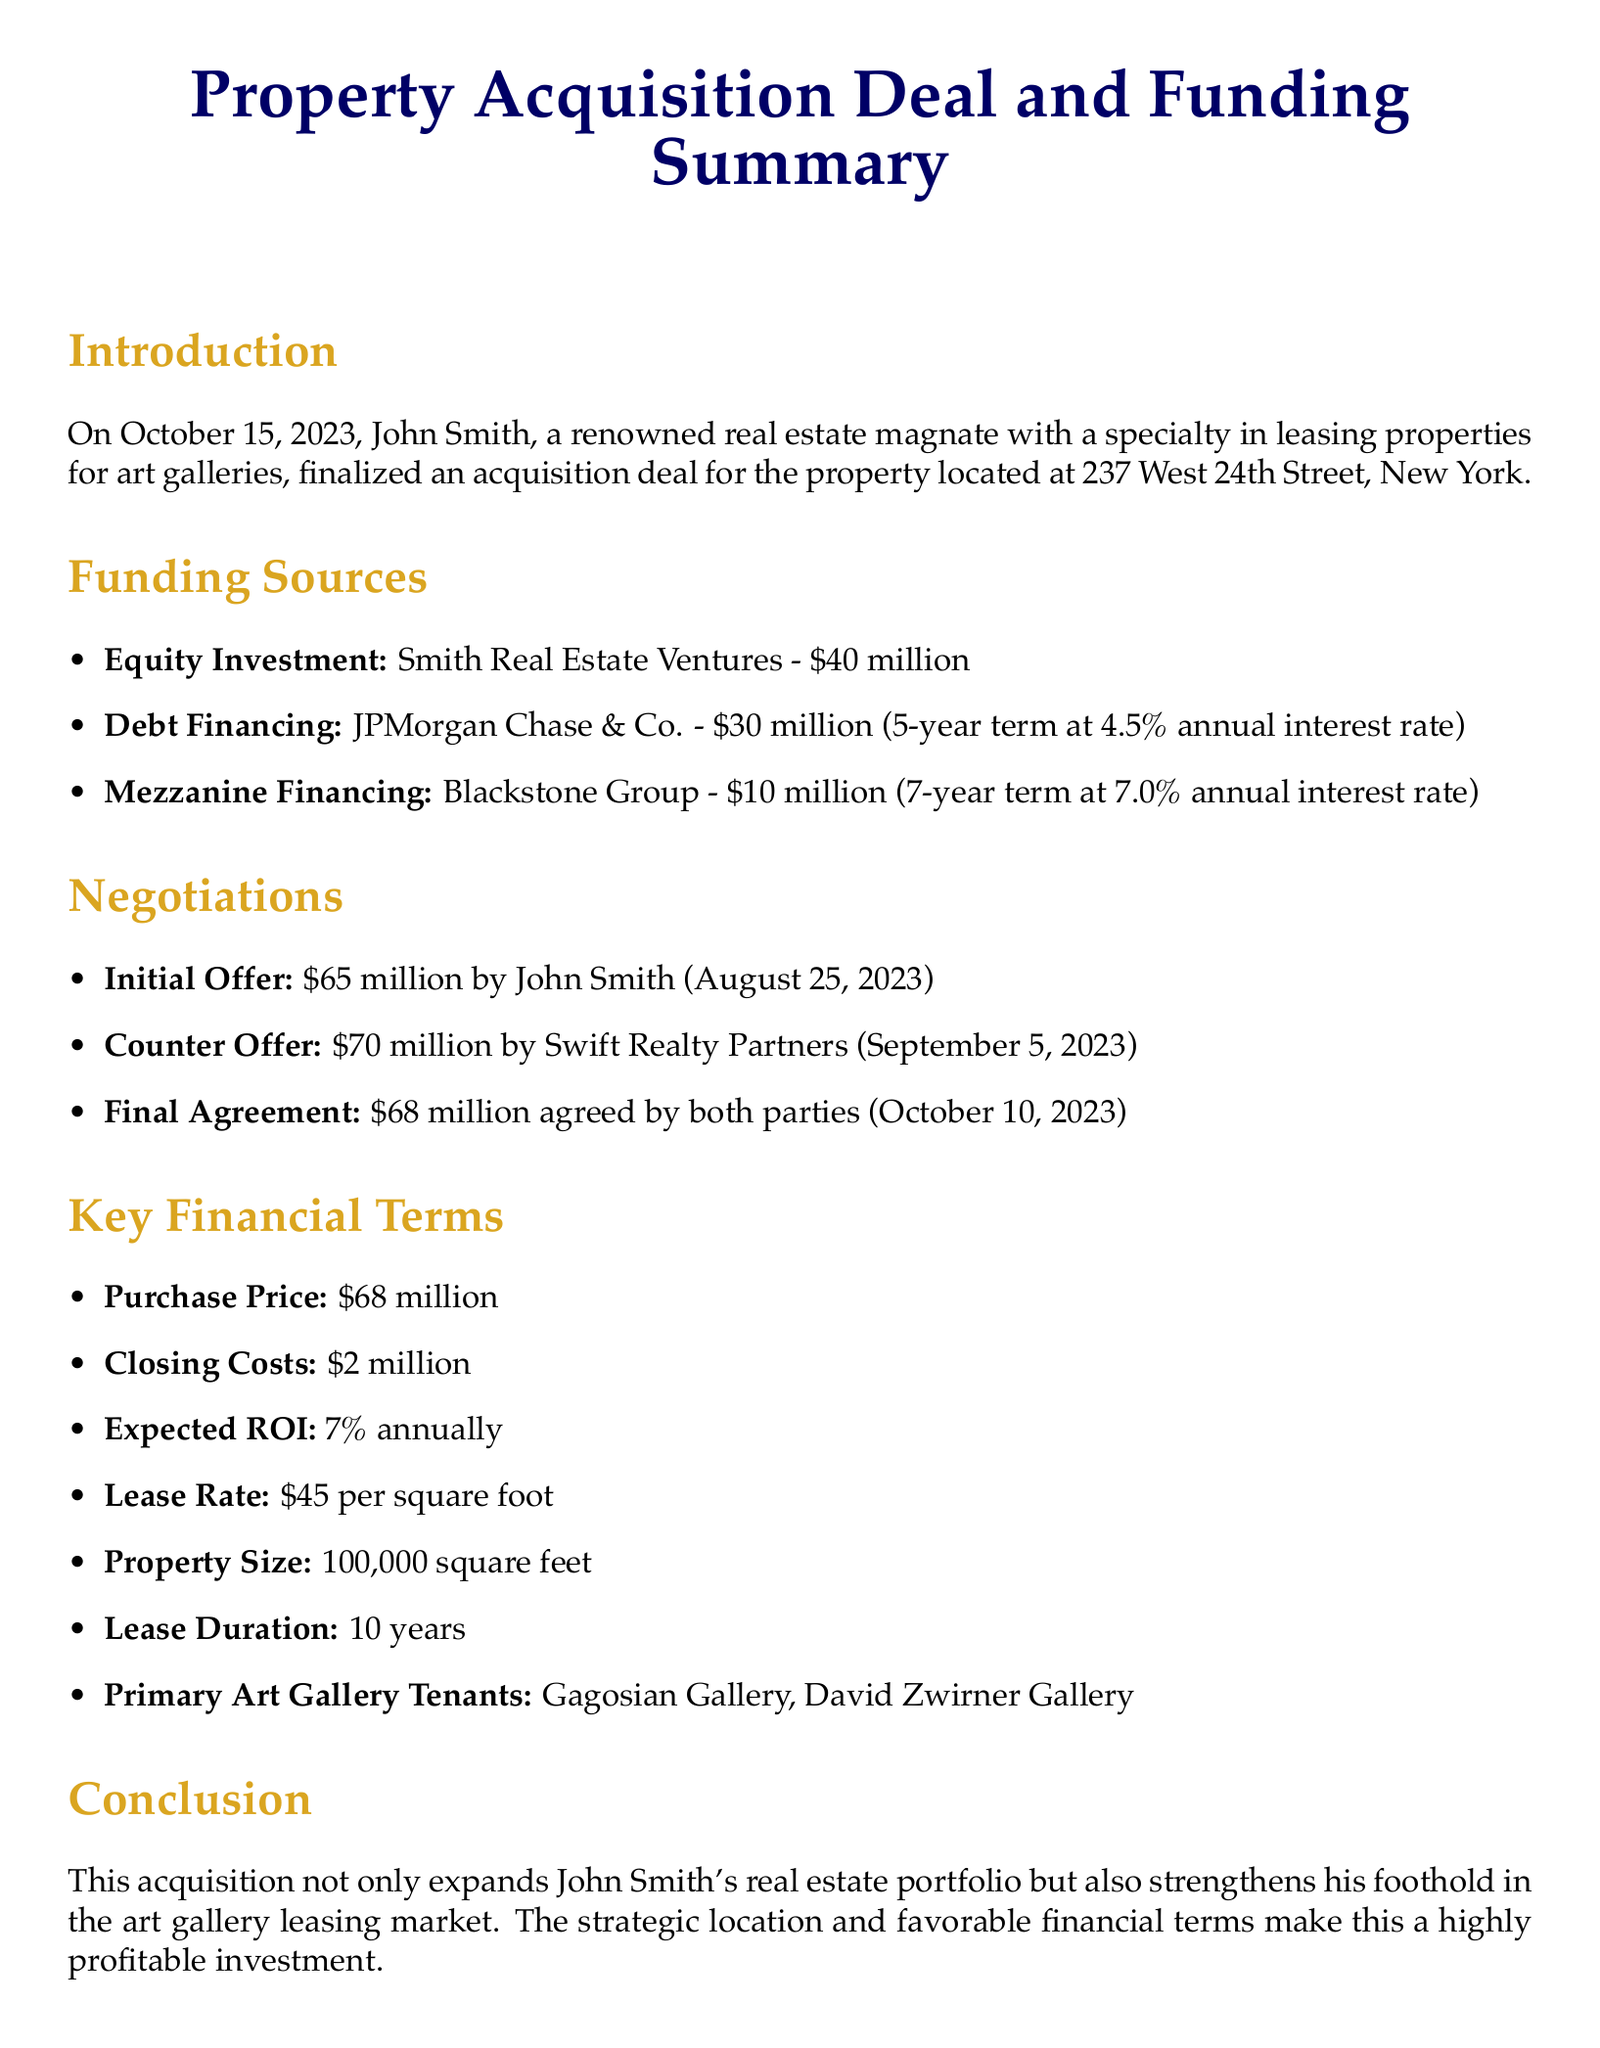What is the acquisition date? The acquisition date mentioned in the document is October 15, 2023.
Answer: October 15, 2023 Who is the seller? The document does not specify a seller name, focusing instead on John Smith as the buyer.
Answer: Not specified What is the total equity investment amount? The equity investment amount is specifically listed as $40 million in the funding sources.
Answer: $40 million What was the initial offer made by John Smith? The initial offer made by John Smith was $65 million on August 25, 2023.
Answer: $65 million What is the expected ROI mentioned in the document? The expected ROI mentioned in the key financial terms section is 7% annually.
Answer: 7% How long is the lease duration? The lease duration specified in the document is 10 years.
Answer: 10 years What is the final agreed purchase price? The final agreed purchase price between the parties is stated as $68 million.
Answer: $68 million Which two galleries are listed as primary tenants? The document lists Gagosian Gallery and David Zwirner Gallery as primary tenants.
Answer: Gagosian Gallery, David Zwirner Gallery What is the total amount of debt financing? The debt financing is outlined as $30 million provided by JPMorgan Chase & Co.
Answer: $30 million What is the closing cost for the acquisition? The closing cost for the acquisition is stated to be $2 million.
Answer: $2 million 